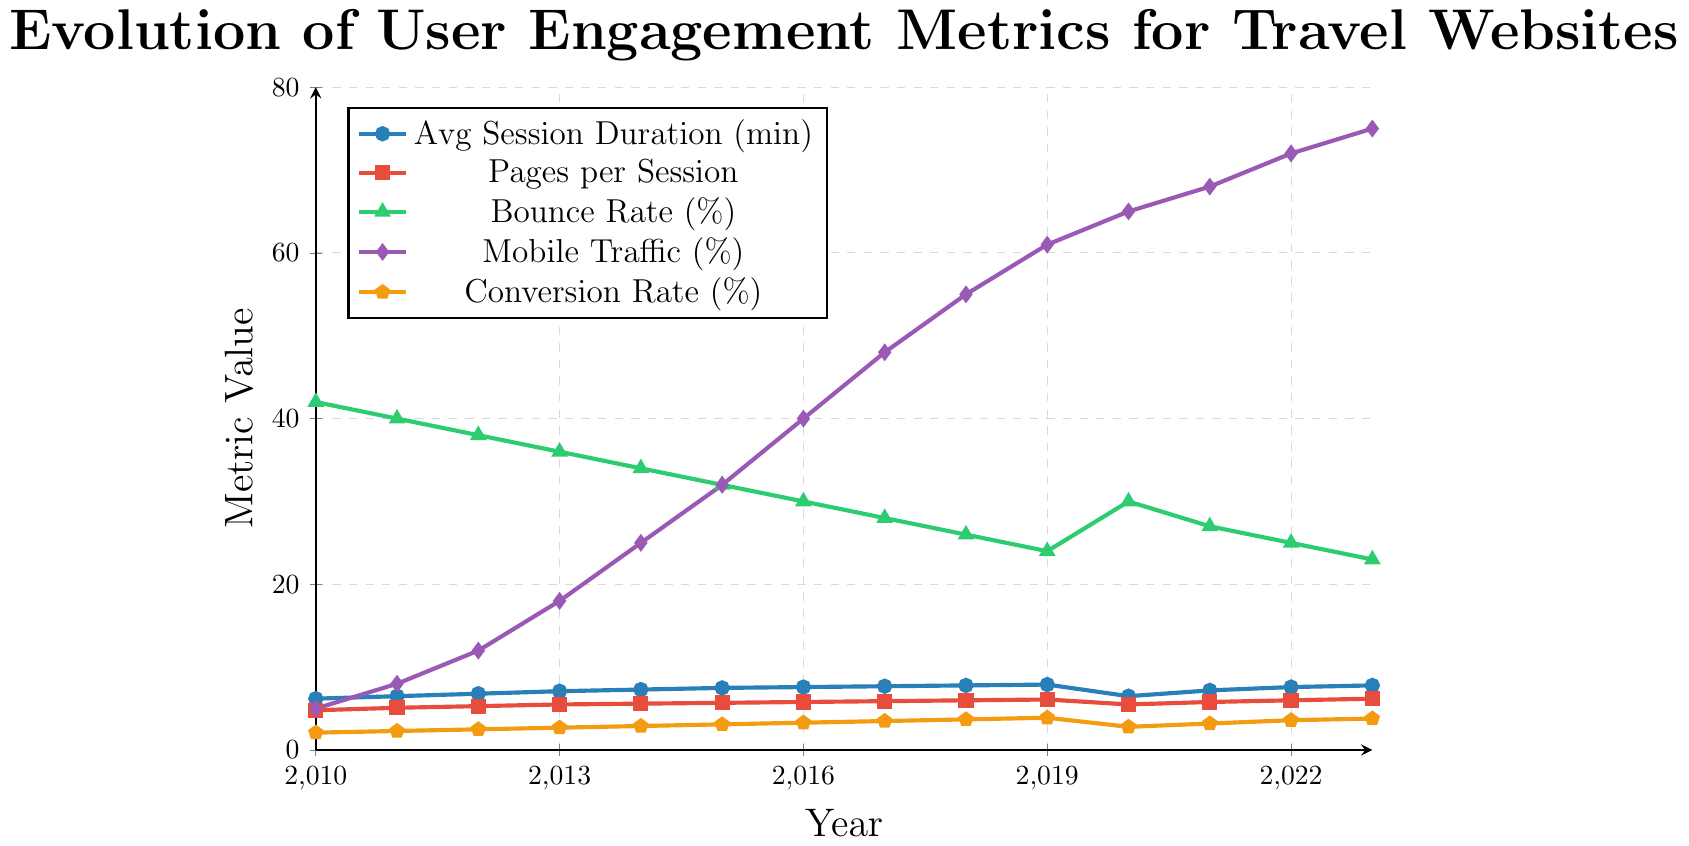What years show a decrease in the average session duration? From the plot, the average session duration decreases between 2019-2020. Other years show an increase or stay the same.
Answer: 2019-2020 Between which years did mobile traffic see the largest increase? By comparing the mobile traffic percentage year-by-year, the increase is largest between 2012 and 2013 where it jumps from 12% to 18%, a 6% increase.
Answer: 2012-2013 Which year had the lowest bounce rate? The bounce rate for each year is shown, with the lowest value at 23% in 2023.
Answer: 2023 What was the conversion rate trend between 2018 and 2020? Conversion rate increased from 3.7% in 2018, peaked at 3.9% in 2019, and then dropped to 2.8% in 2020.
Answer: Increased and then decreased Which metric experienced the most significant change from 2010 to 2023? By examining the overall changes, mobile traffic increased from 5% in 2010 to 75% in 2023, which is the most significant change.
Answer: Mobile Traffic Compare the bounce rate and average session duration in 2023. Which one is higher in metric value and by how much? Bounce rate in 2023 is 23%, and average session duration is 7.8 minutes. Convert session duration to percentage for comparison. Since 7.8% is less than 23%, bounce rate is higher by 23 - 7.8 = 15.2%.
Answer: Bounce rate by 15.2% What is the general trend of 'Pages per Session' from 2010 to 2023? Observing the data points from 2010 to 2023, the trend shows a steady increase from 4.8 to 6.2.
Answer: Steady increase By how much did the conversion rate increase from 2010 to 2019? The conversion rate in 2010 was 2.1%, and in 2019 it was 3.9%. The increase is 3.9 - 2.1 = 1.8%.
Answer: 1.8% What were the values of pages per session and conversion rate at their peaks? Pages per session peaked at 6.2 in 2023, and conversion rate peaked at 3.9% in 2019.
Answer: 6.2 (Pages per Session), 3.9% (Conversion Rate) Identify the year with the largest decline in average session duration. The largest decline is between 2019 (7.9 minutes) and 2020 (6.5 minutes), a drop of 1.4 minutes.
Answer: 2019-2020 